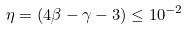<formula> <loc_0><loc_0><loc_500><loc_500>\eta = ( 4 \beta - \gamma - 3 ) \leq 1 0 ^ { - 2 }</formula> 